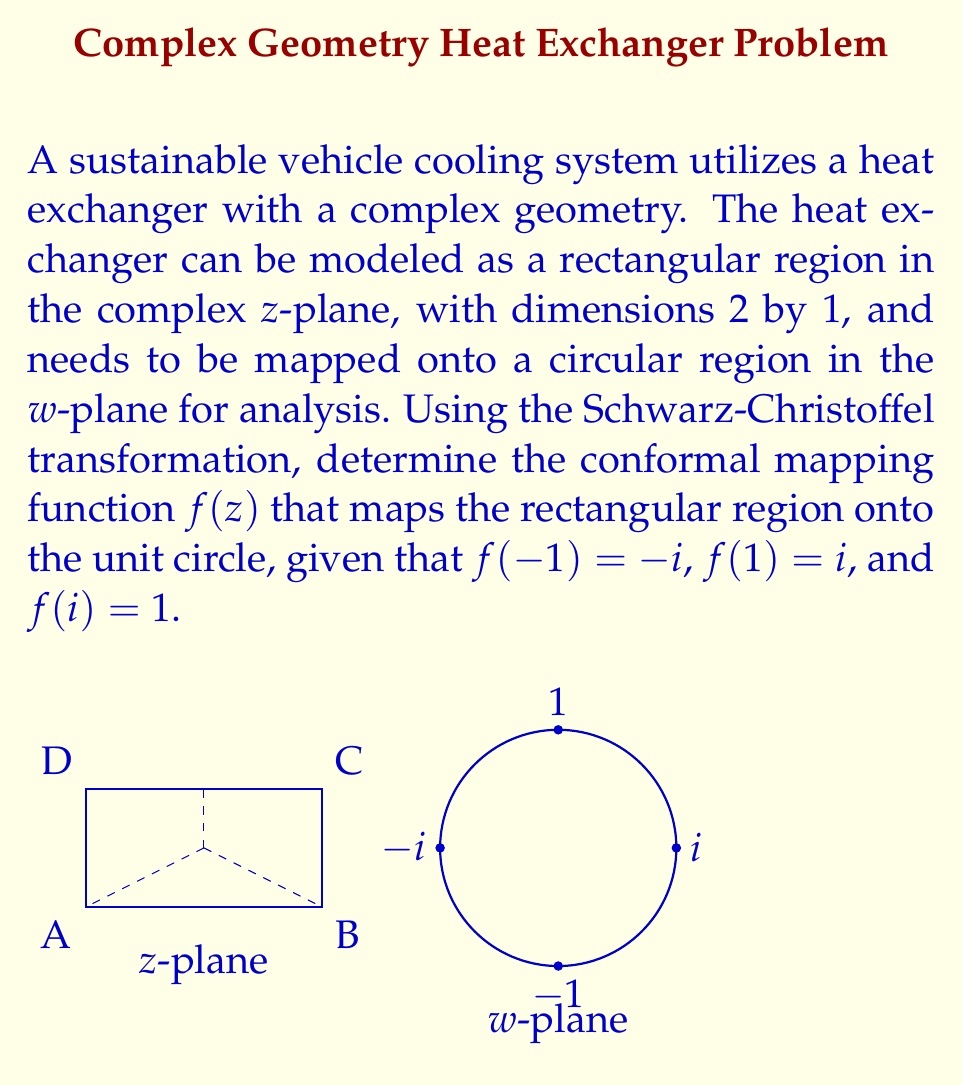Can you answer this question? To solve this problem, we'll follow these steps:

1) The general form of the Schwarz-Christoffel transformation for mapping a rectangle to the upper half-plane is:

   $$f(z) = A \int \frac{dz}{\sqrt{(1-z^2)(1-k^2z^2)}} + B$$

   where k is the modulus of the elliptic function.

2) For our case, we need to compose this with a Möbius transformation to map the upper half-plane to the unit circle. The composition will give us:

   $$w = f(z) = \frac{i-\text{sn}(Kz,k)}{1-i\text{sn}(Kz,k)}$$

   where sn is the Jacobi elliptic function, K is the complete elliptic integral of the first kind, and k is the modulus.

3) Given the mapping conditions:
   f(-1) = -i
   f(1) = i
   f(i) = 1

4) The condition f(i) = 1 implies that i corresponds to K' in the z-plane, where K' is the complementary complete elliptic integral. This gives us the relation:

   $$\frac{K'}{K} = i$$

5) This relation is satisfied when k = 1/√2. We can verify this using the identity:

   $$K'(k) = K(\sqrt{1-k^2})$$

6) With k = 1/√2, we have K = K', and our mapping function becomes:

   $$w = f(z) = \frac{i-\text{sn}(Kz,1/\sqrt{2})}{1-i\text{sn}(Kz,1/\sqrt{2})}$$

7) The value of K can be calculated numerically: K ≈ 1.854074677301372

Therefore, the final conformal mapping function is:

$$w = f(z) = \frac{i-\text{sn}(1.854074677301372z,1/\sqrt{2})}{1-i\text{sn}(1.854074677301372z,1/\sqrt{2})}$$

This function maps the rectangular region in the z-plane onto the unit circle in the w-plane, satisfying all given conditions.
Answer: $$f(z) = \frac{i-\text{sn}(1.854074677301372z,1/\sqrt{2})}{1-i\text{sn}(1.854074677301372z,1/\sqrt{2})}$$ 